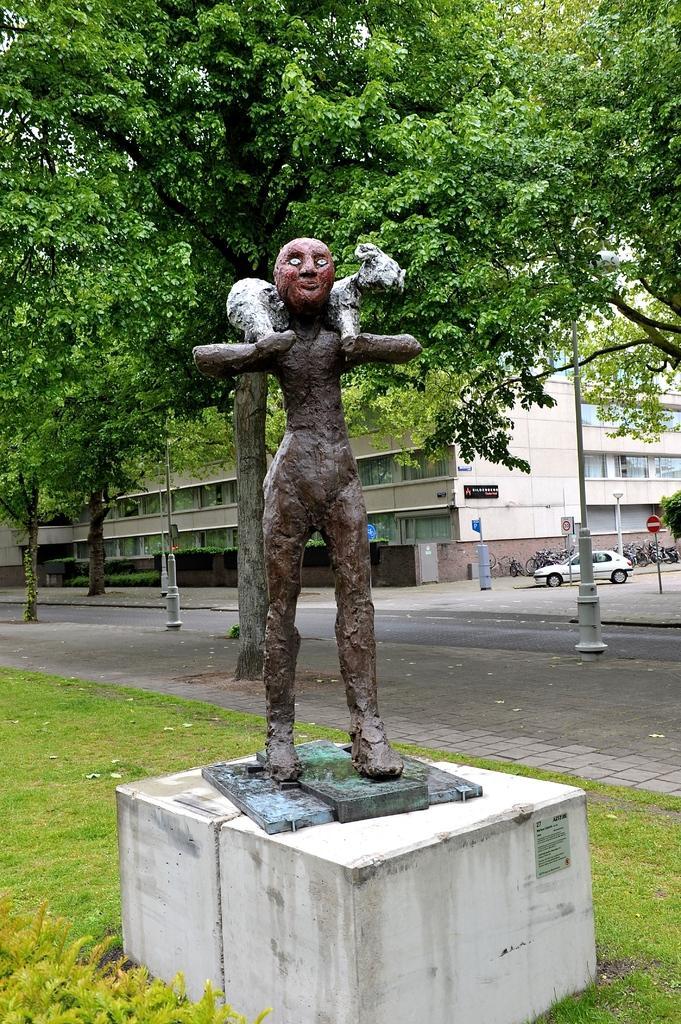How would you summarize this image in a sentence or two? In the foreground of this image, there is a sculpture and the grass around it. In the background, there is a road, pavement, few moles, a sign board, a vehicle moving on the road, few bicycles, a building and the trees. 